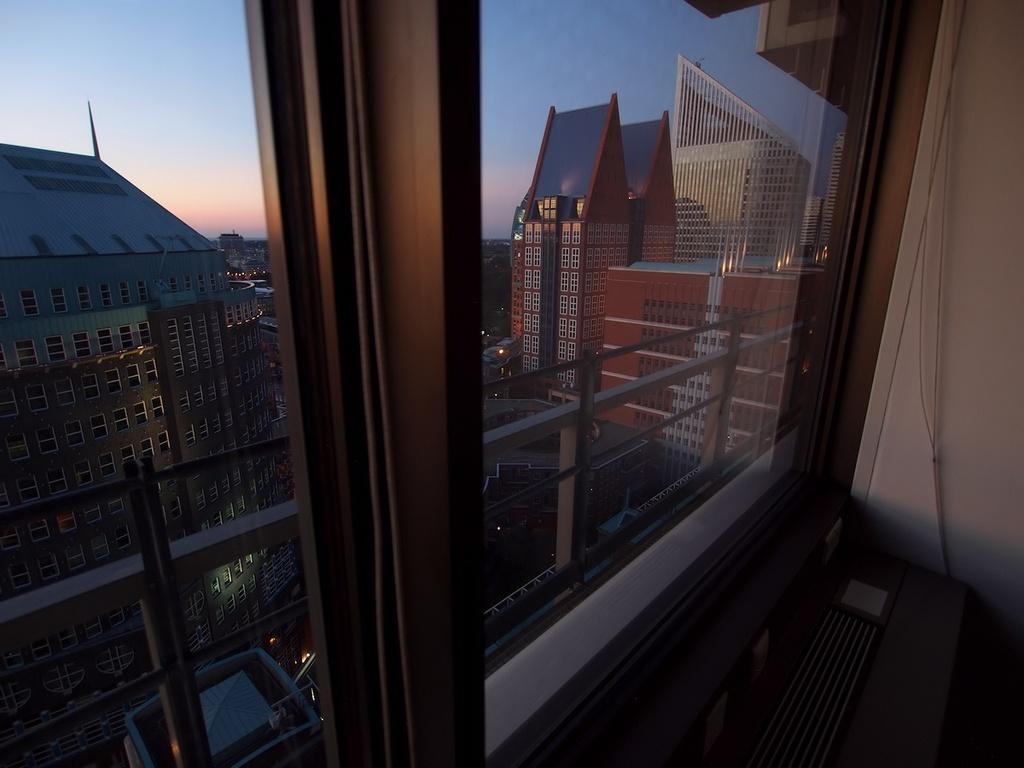In one or two sentences, can you explain what this image depicts? In this image I can see glass window, another side of the window I can see some buildings, vehicles on the road. 